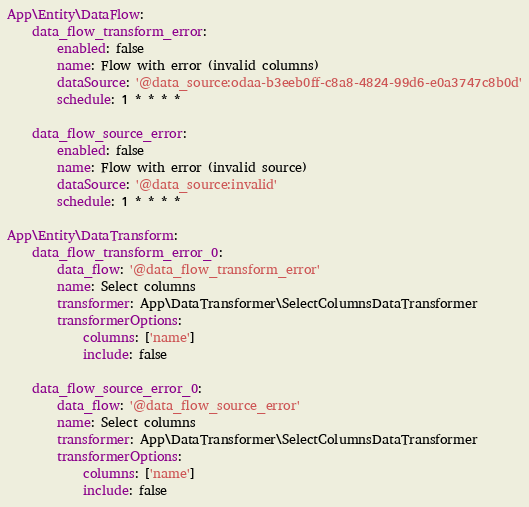Convert code to text. <code><loc_0><loc_0><loc_500><loc_500><_YAML_>App\Entity\DataFlow:
    data_flow_transform_error:
        enabled: false
        name: Flow with error (invalid columns)
        dataSource: '@data_source:odaa-b3eeb0ff-c8a8-4824-99d6-e0a3747c8b0d'
        schedule: 1 * * * *

    data_flow_source_error:
        enabled: false
        name: Flow with error (invalid source)
        dataSource: '@data_source:invalid'
        schedule: 1 * * * *

App\Entity\DataTransform:
    data_flow_transform_error_0:
        data_flow: '@data_flow_transform_error'
        name: Select columns
        transformer: App\DataTransformer\SelectColumnsDataTransformer
        transformerOptions:
            columns: ['name']
            include: false

    data_flow_source_error_0:
        data_flow: '@data_flow_source_error'
        name: Select columns
        transformer: App\DataTransformer\SelectColumnsDataTransformer
        transformerOptions:
            columns: ['name']
            include: false
</code> 